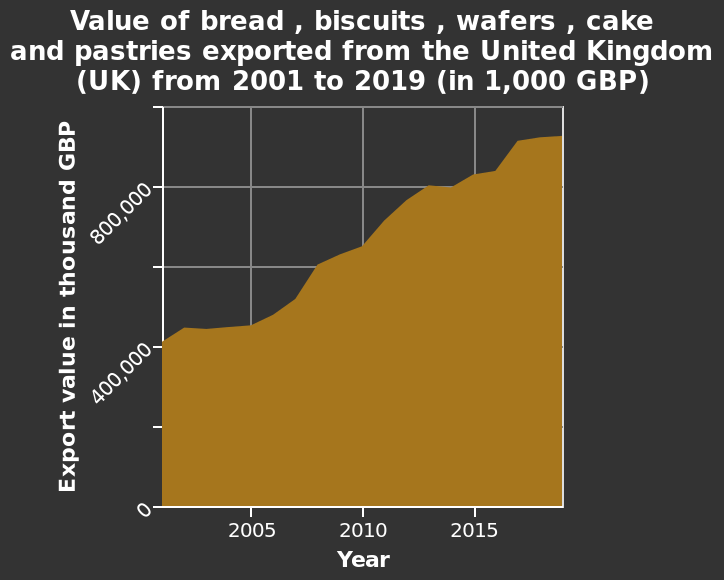<image>
please enumerates aspects of the construction of the chart Here a area graph is titled Value of bread , biscuits , wafers , cake and pastries exported from the United Kingdom (UK) from 2001 to 2019 (in 1,000 GBP). On the x-axis, Year is drawn. A linear scale with a minimum of 0 and a maximum of 1,000,000 can be seen on the y-axis, labeled Export value in thousand GBP. In how many years did the export value double? The export value doubled over approximately 11 years, from 2001 to around 2012. What is shown on the x-axis of the area graph? The x-axis of the area graph represents the years from 2001 to 2019. 